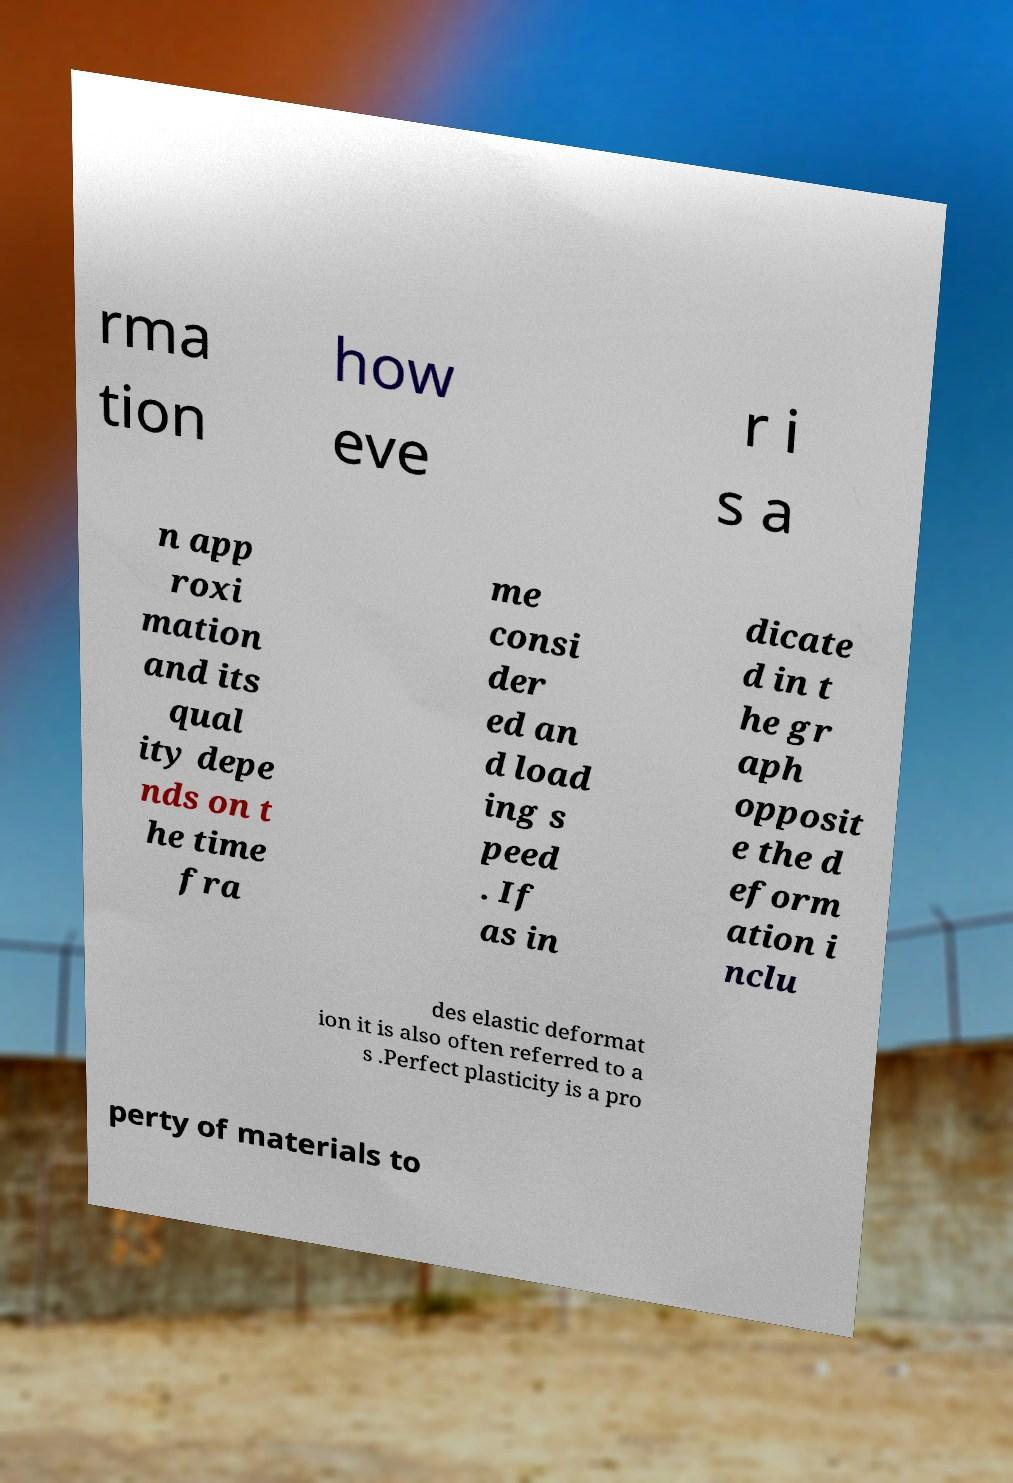Could you assist in decoding the text presented in this image and type it out clearly? rma tion how eve r i s a n app roxi mation and its qual ity depe nds on t he time fra me consi der ed an d load ing s peed . If as in dicate d in t he gr aph opposit e the d eform ation i nclu des elastic deformat ion it is also often referred to a s .Perfect plasticity is a pro perty of materials to 